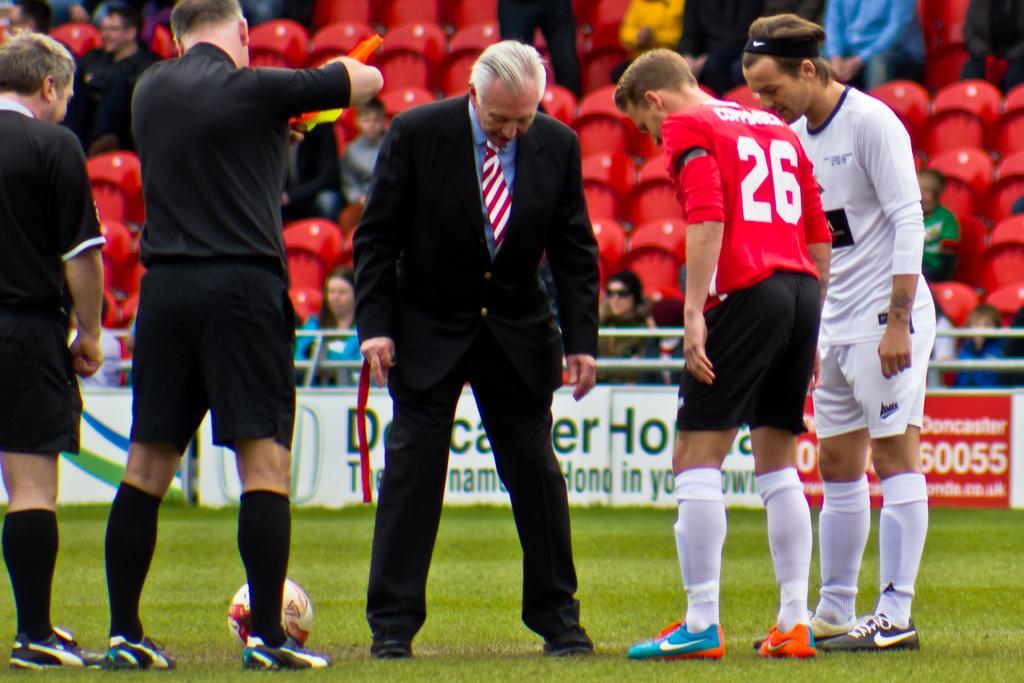Please provide a concise description of this image. This picture is clicked in a stadium. There are five men standing on the grass and looking down. The man in the center is wearing a black suit and the other four are wearing jerseys. There is a ball on the ground. Behind them there are boards on the ground with text on it. In the background there are chairs and people are sitting on them. 